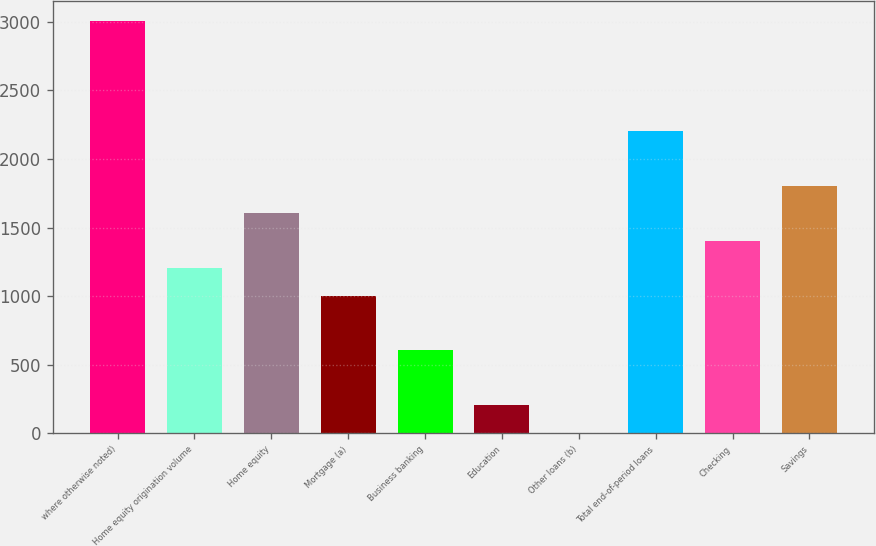Convert chart. <chart><loc_0><loc_0><loc_500><loc_500><bar_chart><fcel>where otherwise noted)<fcel>Home equity origination volume<fcel>Home equity<fcel>Mortgage (a)<fcel>Business banking<fcel>Education<fcel>Other loans (b)<fcel>Total end-of-period loans<fcel>Checking<fcel>Savings<nl><fcel>3006.2<fcel>1204.04<fcel>1604.52<fcel>1003.8<fcel>603.32<fcel>202.84<fcel>2.6<fcel>2205.24<fcel>1404.28<fcel>1804.76<nl></chart> 